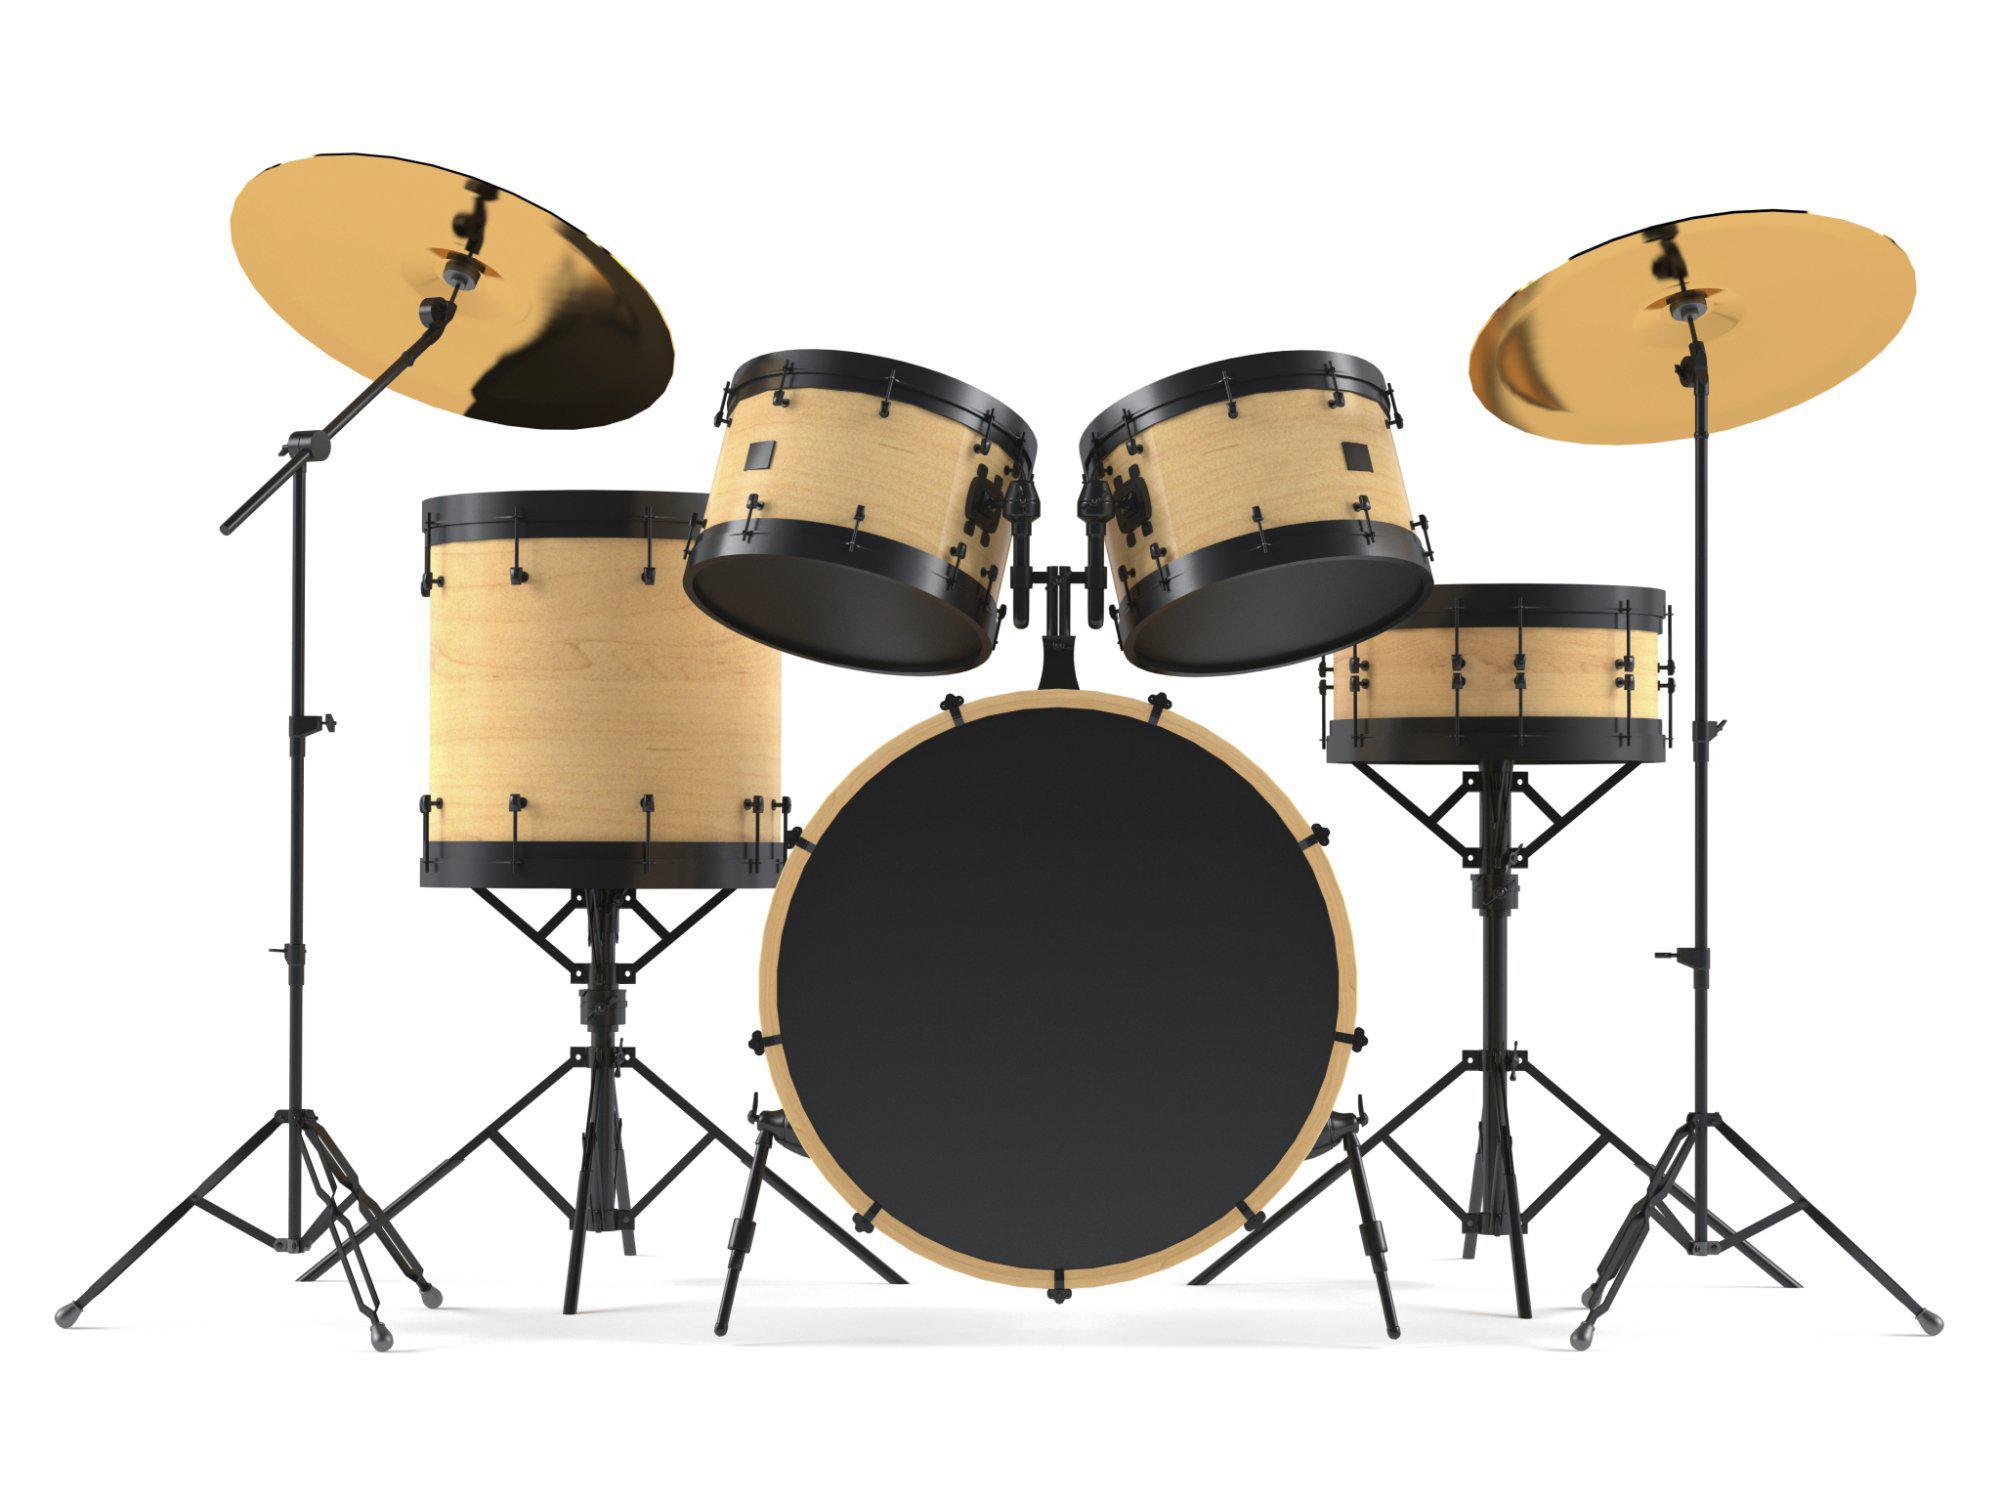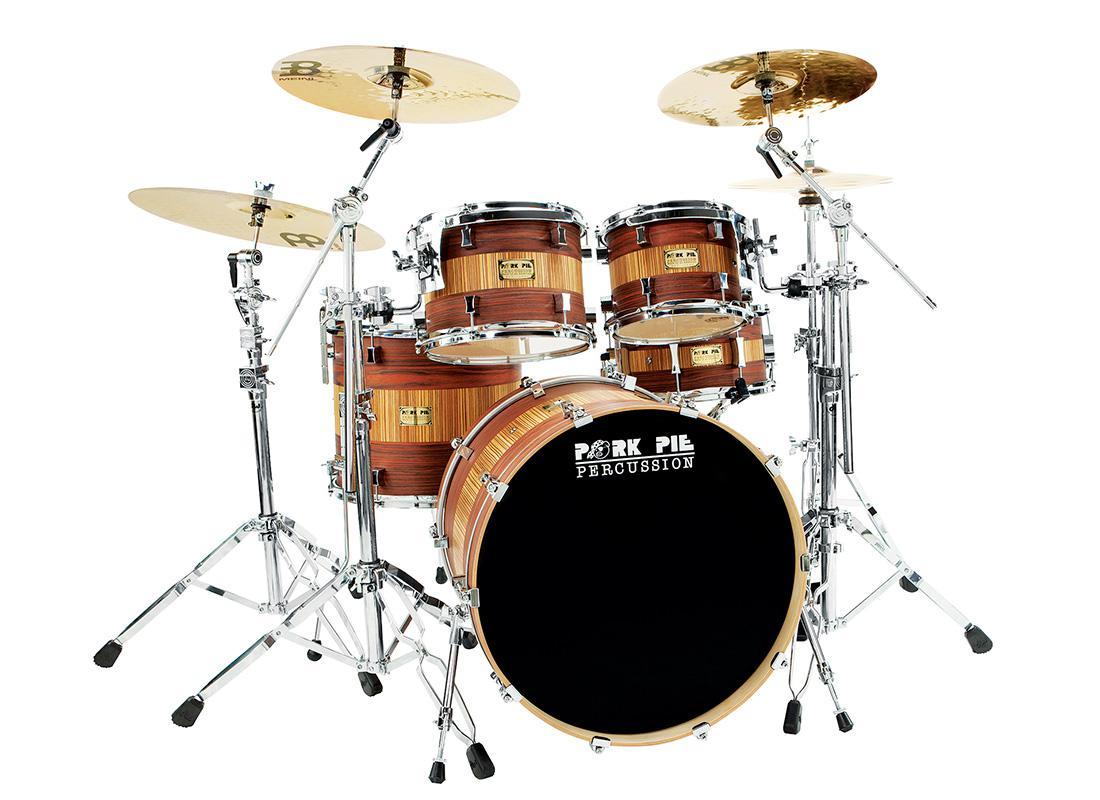The first image is the image on the left, the second image is the image on the right. Considering the images on both sides, is "One image features a drum kit with the central large drum showing a black round side, and the other image features a drum kit with the central large drum showing a round white side." valid? Answer yes or no. No. The first image is the image on the left, the second image is the image on the right. Assess this claim about the two images: "The kick drum skin in the left image is black.". Correct or not? Answer yes or no. Yes. 